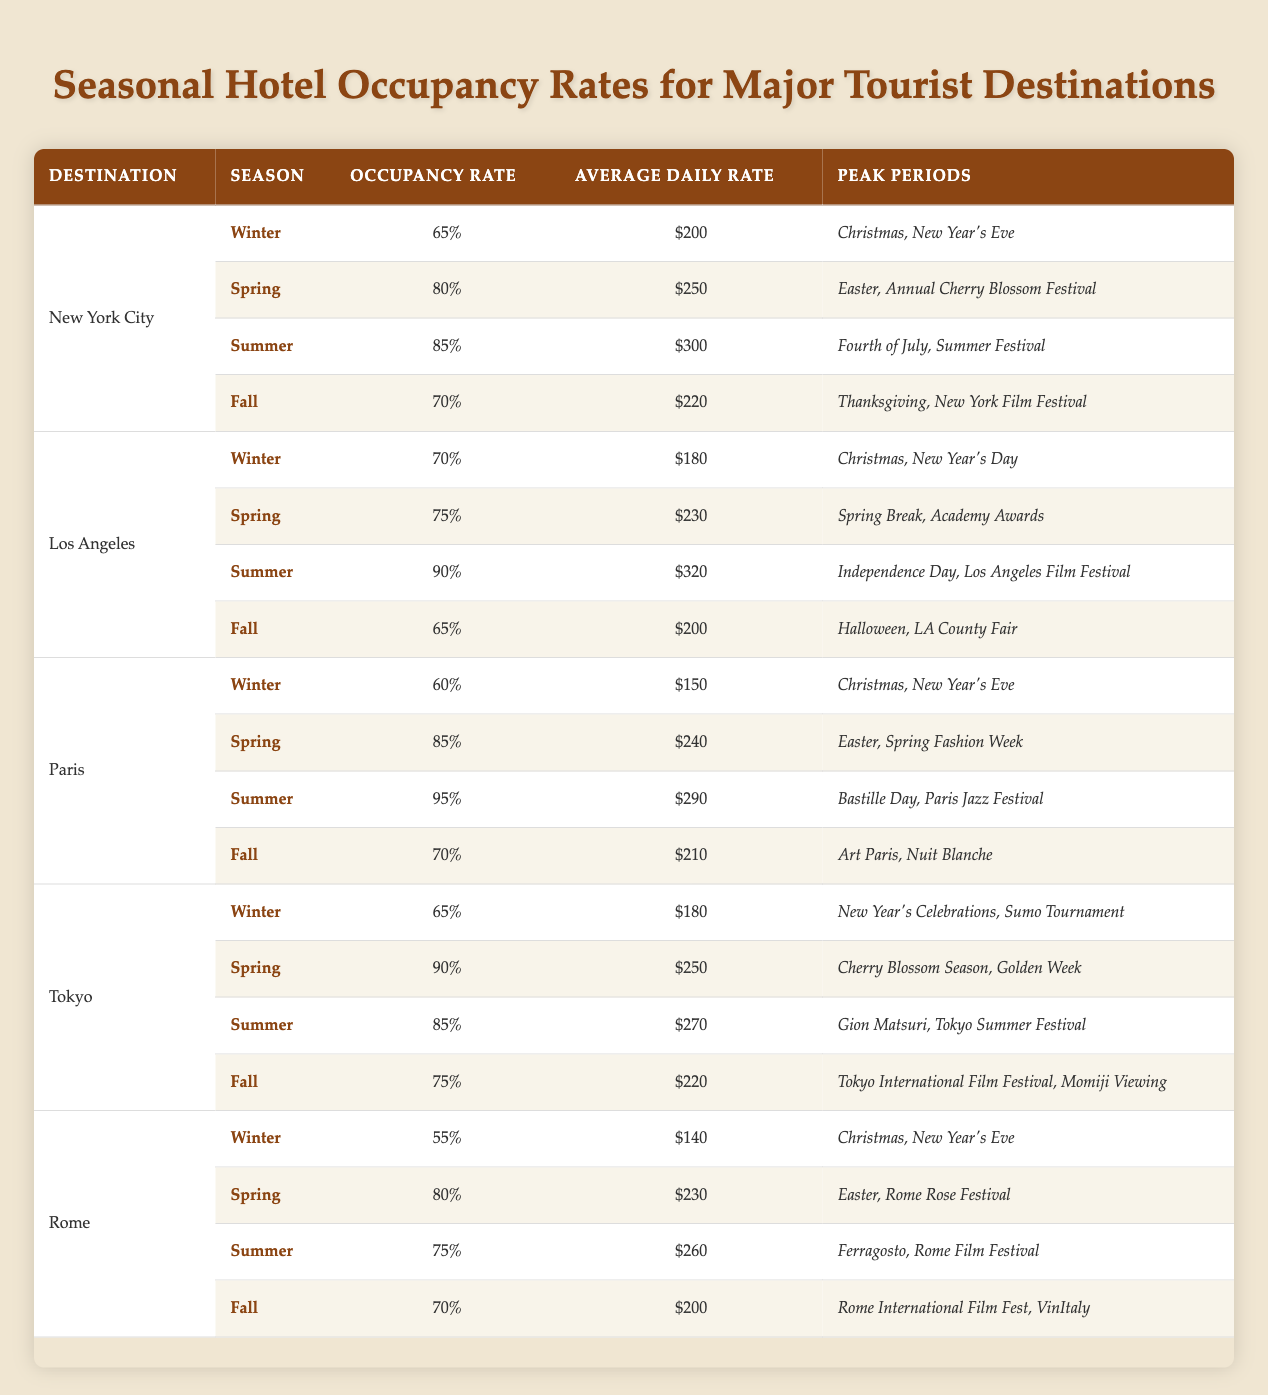What is the occupancy rate for hotels in New York City during the Summer season? The table shows that for New York City in the Summer season, the occupancy rate is listed as 85%.
Answer: 85% Which destination has the highest occupancy rate in the Spring season? By comparing the Spring occupancy rates for all destinations in the table, Paris has the highest rate at 85%.
Answer: Paris What is the average daily rate for hotels in Tokyo during the Winter season? The table indicates that Tokyo's average daily rate during Winter is $180.
Answer: $180 Is the occupancy rate for hotels in Los Angeles during Fall higher than that in New York City during the same season? Los Angeles has a Fall occupancy rate of 65%, while New York City has a Fall rate of 70%. Since 65% is not higher than 70%, the answer is no.
Answer: No What is the combined average daily rate for hotels in Rome during Spring and Summer? The average daily rates for Rome in Spring and Summer are $230 and $260 respectively. Adding them gives $230 + $260 = $490. Since there are two seasons, the average is $490 / 2 = $245.
Answer: $245 Which season has the lowest occupancy rate for hotels in all listed destinations? By examining all seasons across each destination, the lowest occupancy rate is 55%, recorded in Rome during Winter.
Answer: 55% Is the occupancy rate in Paris during Summer higher than in Tokyo during Winter? Paris has a Summer occupancy rate of 95% and Tokyo has a Winter occupancy rate of 65%. Since 95% is higher than 65%, the answer is yes.
Answer: Yes What is the difference in occupancy rates between Los Angeles in Spring and New York City in Winter? The occupancy rate for Los Angeles in Spring is 75% while New York City in Winter is 65%. The difference is 75% - 65% = 10%.
Answer: 10% 